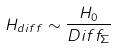<formula> <loc_0><loc_0><loc_500><loc_500>H _ { d i f f } \sim \frac { H _ { 0 } } { D i f f _ { \Sigma } }</formula> 